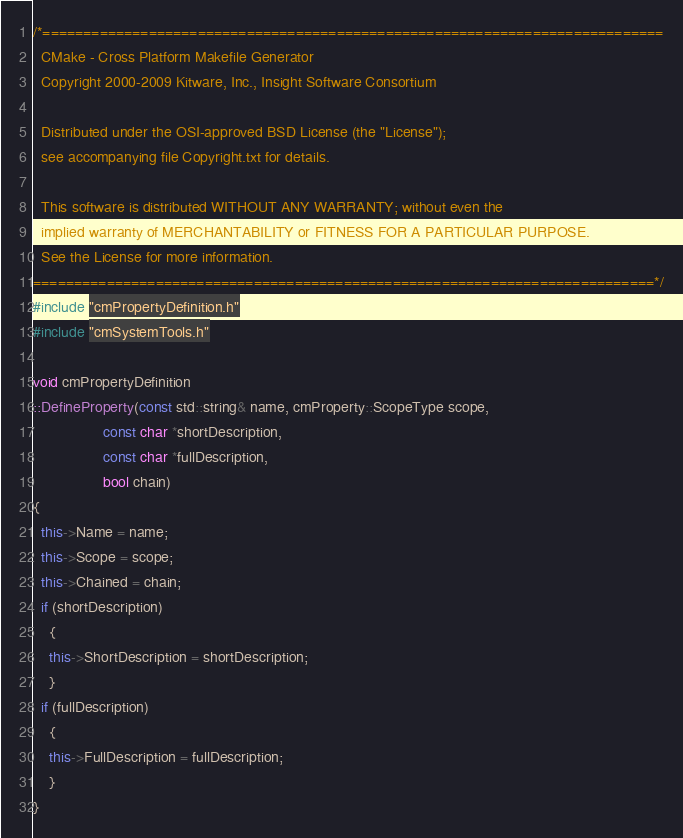<code> <loc_0><loc_0><loc_500><loc_500><_C++_>/*============================================================================
  CMake - Cross Platform Makefile Generator
  Copyright 2000-2009 Kitware, Inc., Insight Software Consortium

  Distributed under the OSI-approved BSD License (the "License");
  see accompanying file Copyright.txt for details.

  This software is distributed WITHOUT ANY WARRANTY; without even the
  implied warranty of MERCHANTABILITY or FITNESS FOR A PARTICULAR PURPOSE.
  See the License for more information.
============================================================================*/
#include "cmPropertyDefinition.h"
#include "cmSystemTools.h"

void cmPropertyDefinition
::DefineProperty(const std::string& name, cmProperty::ScopeType scope,
                 const char *shortDescription,
                 const char *fullDescription,
                 bool chain)
{
  this->Name = name;
  this->Scope = scope;
  this->Chained = chain;
  if (shortDescription)
    {
    this->ShortDescription = shortDescription;
    }
  if (fullDescription)
    {
    this->FullDescription = fullDescription;
    }
}

</code> 